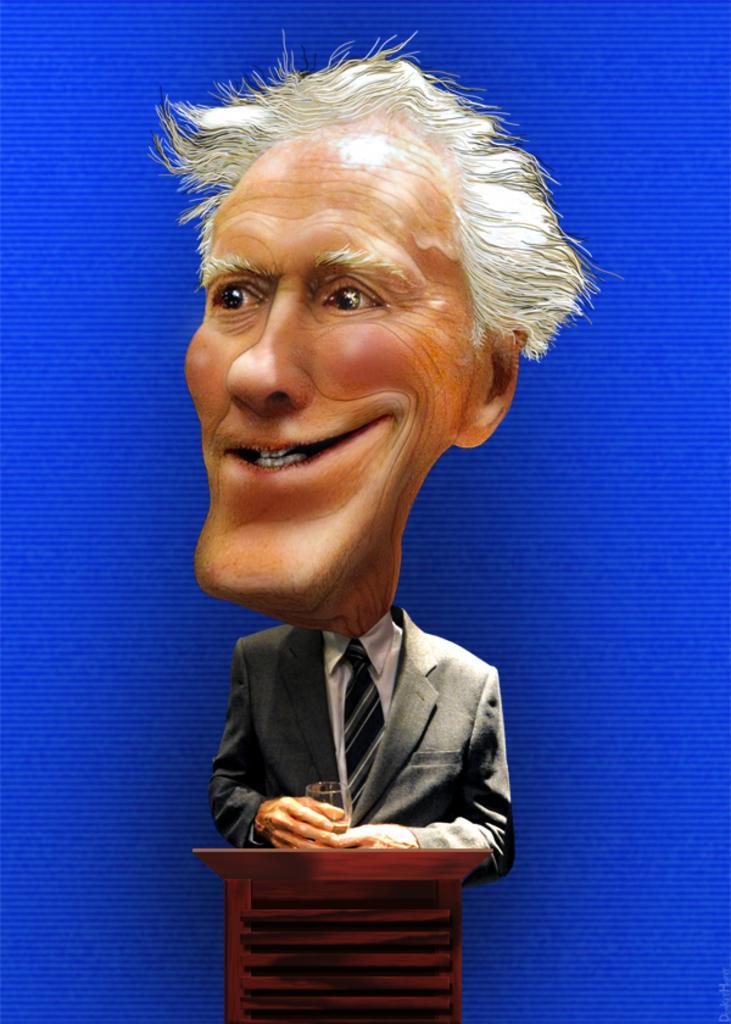Please provide a concise description of this image. In front of the image there is a depiction of a person holding the glass. In front of him there is a podium. Background color of the image is blue. There is some text on the right side of the image. 